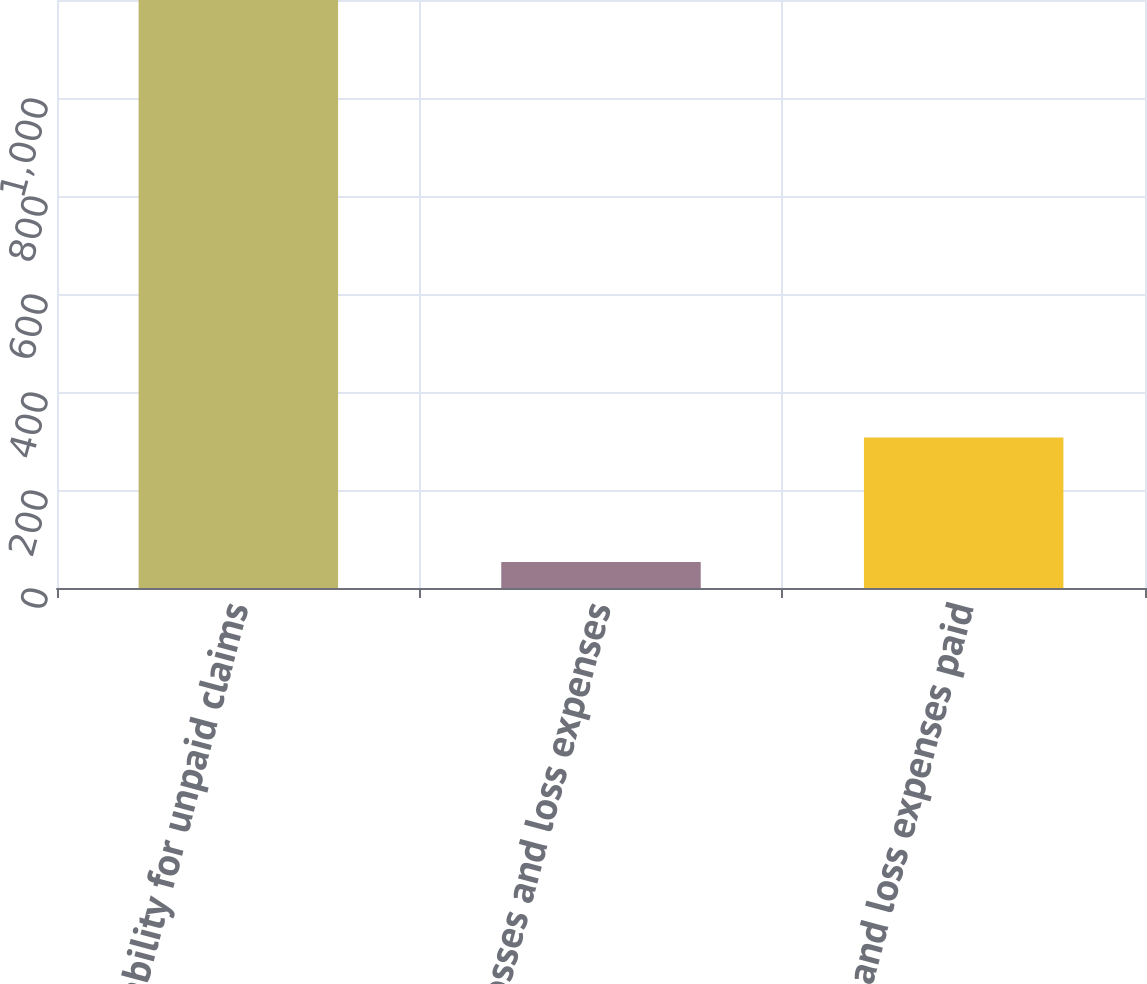<chart> <loc_0><loc_0><loc_500><loc_500><bar_chart><fcel>Liability for unpaid claims<fcel>Losses and loss expenses<fcel>Losses and loss expenses paid<nl><fcel>1200<fcel>53<fcel>307<nl></chart> 